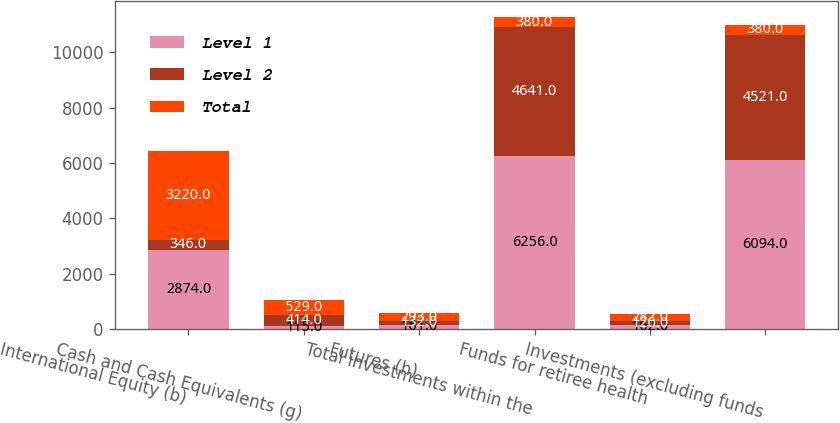Convert chart to OTSL. <chart><loc_0><loc_0><loc_500><loc_500><stacked_bar_chart><ecel><fcel>International Equity (b)<fcel>Cash and Cash Equivalents (g)<fcel>Futures (h)<fcel>Total investments within the<fcel>Funds for retiree health<fcel>Investments (excluding funds<nl><fcel>Level 1<fcel>2874<fcel>115<fcel>161<fcel>6256<fcel>162<fcel>6094<nl><fcel>Level 2<fcel>346<fcel>414<fcel>132<fcel>4641<fcel>120<fcel>4521<nl><fcel>Total<fcel>3220<fcel>529<fcel>293<fcel>380<fcel>282<fcel>380<nl></chart> 